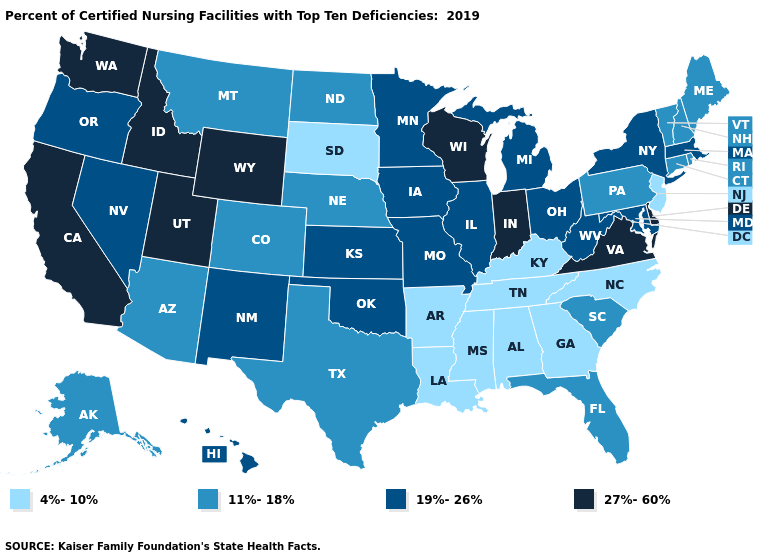What is the value of West Virginia?
Concise answer only. 19%-26%. What is the value of Massachusetts?
Short answer required. 19%-26%. Does Rhode Island have the highest value in the Northeast?
Give a very brief answer. No. What is the value of Utah?
Be succinct. 27%-60%. What is the value of Arkansas?
Give a very brief answer. 4%-10%. Is the legend a continuous bar?
Concise answer only. No. Does New Mexico have the lowest value in the West?
Quick response, please. No. What is the value of Virginia?
Give a very brief answer. 27%-60%. Among the states that border Wisconsin , which have the lowest value?
Give a very brief answer. Illinois, Iowa, Michigan, Minnesota. Does Oklahoma have a lower value than Indiana?
Answer briefly. Yes. Among the states that border North Carolina , does South Carolina have the highest value?
Answer briefly. No. Name the states that have a value in the range 4%-10%?
Short answer required. Alabama, Arkansas, Georgia, Kentucky, Louisiana, Mississippi, New Jersey, North Carolina, South Dakota, Tennessee. What is the highest value in the USA?
Give a very brief answer. 27%-60%. Does Idaho have the highest value in the West?
Give a very brief answer. Yes. Which states have the lowest value in the USA?
Write a very short answer. Alabama, Arkansas, Georgia, Kentucky, Louisiana, Mississippi, New Jersey, North Carolina, South Dakota, Tennessee. 